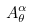Convert formula to latex. <formula><loc_0><loc_0><loc_500><loc_500>A _ { \theta } ^ { \alpha }</formula> 